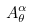Convert formula to latex. <formula><loc_0><loc_0><loc_500><loc_500>A _ { \theta } ^ { \alpha }</formula> 